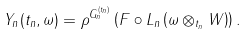<formula> <loc_0><loc_0><loc_500><loc_500>Y _ { n } ( t _ { n } , \omega ) = \rho ^ { G ^ { ( t _ { n } ) } _ { n } } \left ( F \circ L _ { n } \left ( \omega \otimes _ { t _ { n } } W \right ) \right ) .</formula> 